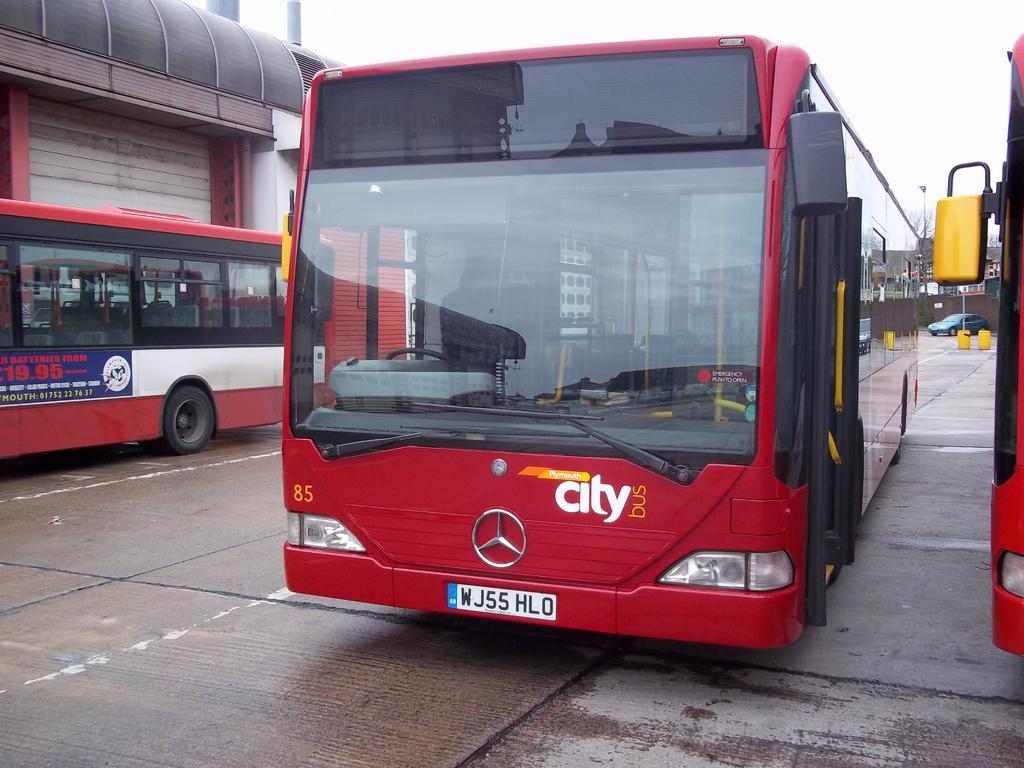What city is mentioned on the front of the bus?
Provide a succinct answer. Plymouth. What is on the license plate?
Make the answer very short. Wj55 hlo. 